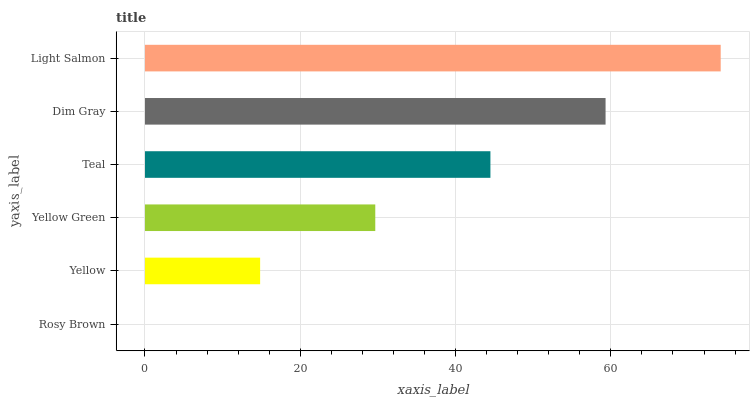Is Rosy Brown the minimum?
Answer yes or no. Yes. Is Light Salmon the maximum?
Answer yes or no. Yes. Is Yellow the minimum?
Answer yes or no. No. Is Yellow the maximum?
Answer yes or no. No. Is Yellow greater than Rosy Brown?
Answer yes or no. Yes. Is Rosy Brown less than Yellow?
Answer yes or no. Yes. Is Rosy Brown greater than Yellow?
Answer yes or no. No. Is Yellow less than Rosy Brown?
Answer yes or no. No. Is Teal the high median?
Answer yes or no. Yes. Is Yellow Green the low median?
Answer yes or no. Yes. Is Light Salmon the high median?
Answer yes or no. No. Is Teal the low median?
Answer yes or no. No. 